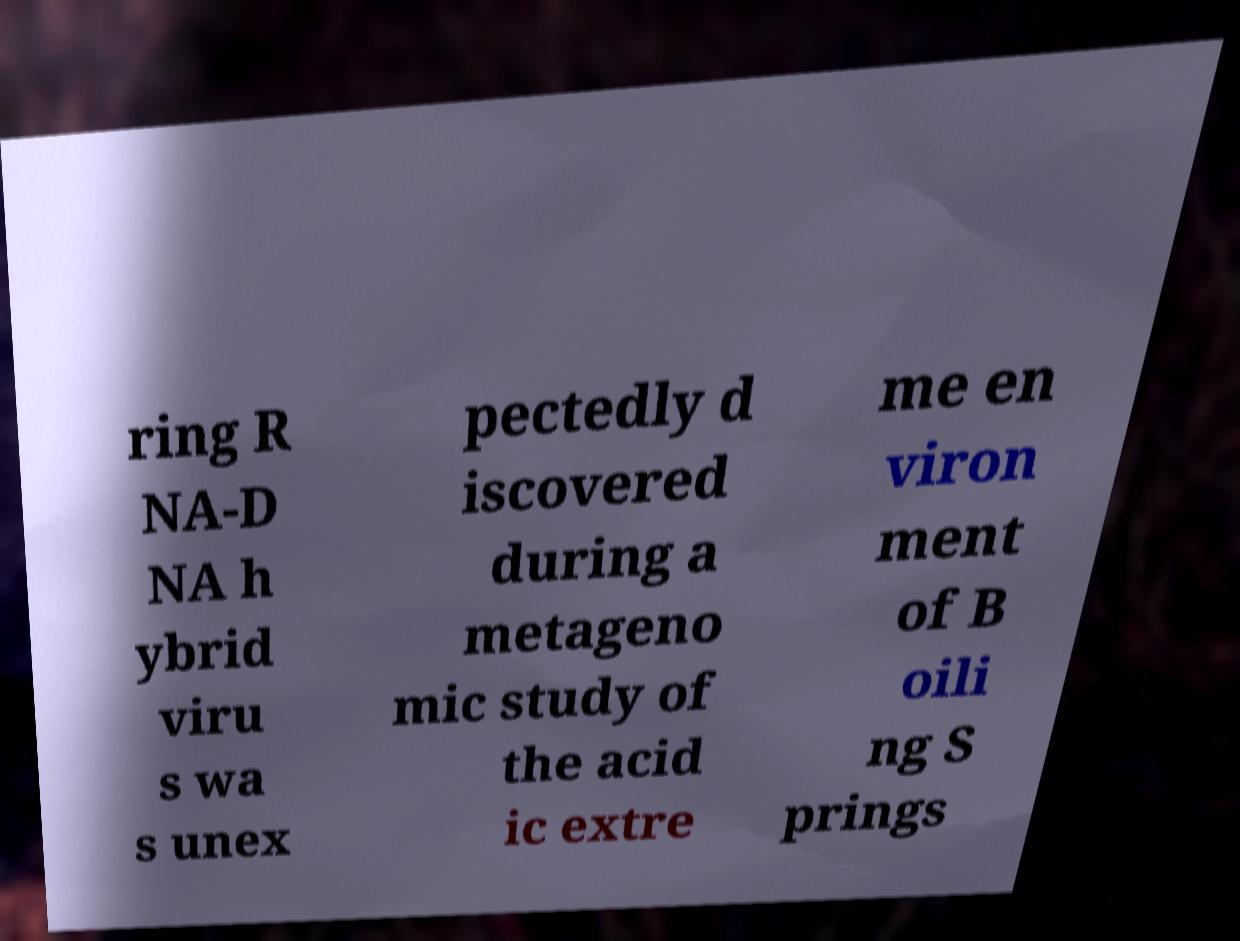Please read and relay the text visible in this image. What does it say? ring R NA-D NA h ybrid viru s wa s unex pectedly d iscovered during a metageno mic study of the acid ic extre me en viron ment of B oili ng S prings 